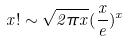<formula> <loc_0><loc_0><loc_500><loc_500>x ! \sim \sqrt { 2 \pi x } ( \frac { x } { e } ) ^ { x }</formula> 